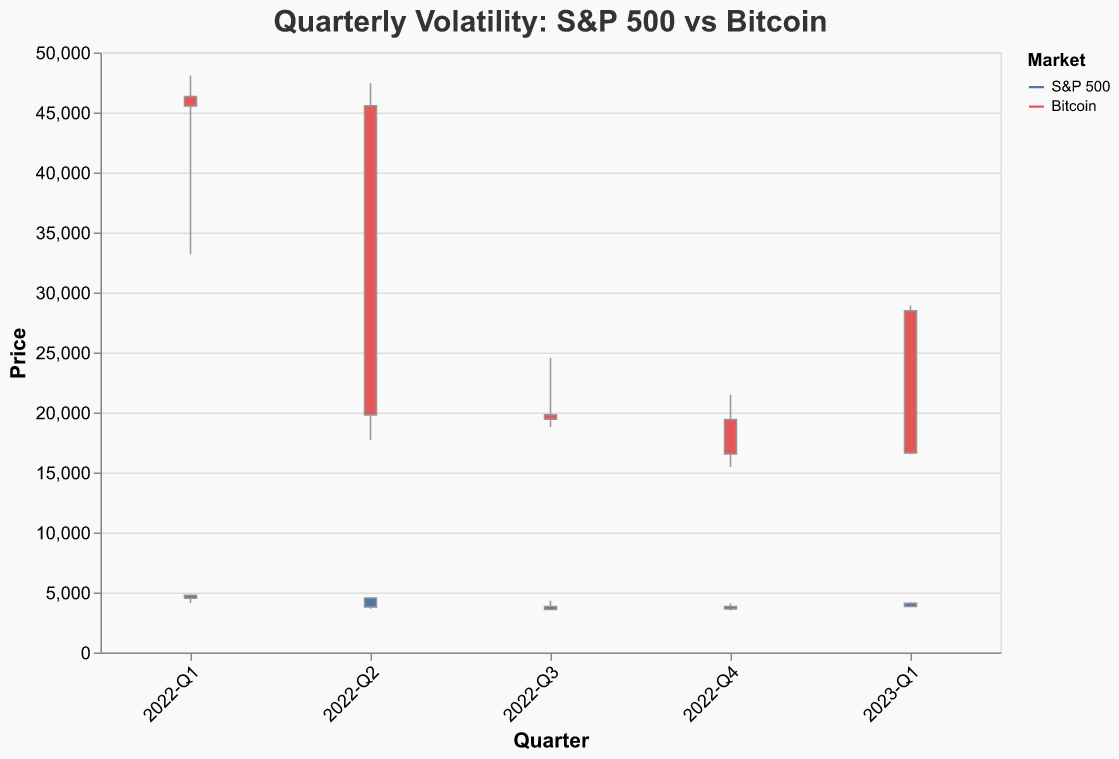What's the title of the figure? The title of a figure is usually displayed at the top; it provides a quick understanding of what the figure is about. Here, the title is "Quarterly Volatility: S&P 500 vs Bitcoin".
Answer: Quarterly Volatility: S&P 500 vs Bitcoin How are the markets differentiated in the figure? The markets are differentiated using colors. The S&P 500 is represented in blue, and Bitcoin is represented in red.
Answer: By color Which quarter shows the highest closing price for Bitcoin? To determine this, examine the "Close" prices for Bitcoin in each quarter. The highest closing price is in 2023-Q1 with 28,478.54.
Answer: 2023-Q1 Compare the overall volatility between the S&P 500 and Bitcoin in 2022. Which market generally shows more volatility? Volatility can be inferred by observing the difference between the high and low prices. In 2022, Bitcoin consistently shows larger ranges between high and low prices compared to the S&P 500, indicating more volatility.
Answer: Bitcoin What was the closing price of S&P 500 in 2023-Q1 and how does it compare to the opening price in the same quarter? To determine this, check the values for S&P 500 in 2023-Q1. The closing price is 4,109.31 and the opening price is 3,824.14. Comparing them, the closing price is higher than the opening price.
Answer: Higher Can you identify any quarter in which both the S&P 500 and Bitcoin closed lower than their opening prices? To identify this, look for quarters where the "Close" price is less than the "Open" price for both markets. This occurs in 2022-Q2 and 2022-Q3.
Answer: 2022-Q2 and 2022-Q3 During which quarter did Bitcoin experience its lowest price and what was that price? Examine the "Low" price for Bitcoin across all quarters. The lowest price occurred in 2022-Q4 at 15,460.85.
Answer: 2022-Q4, 15,460.85 Which quarter has the smallest range (difference between high and low prices) for the S&P 500? To determine this, calculate the difference between the high and low prices for each quarter for the S&P 500. The smallest range is in 2023-Q1 with a range of 386.58 (4195.44 - 3808.86).
Answer: 2023-Q1 